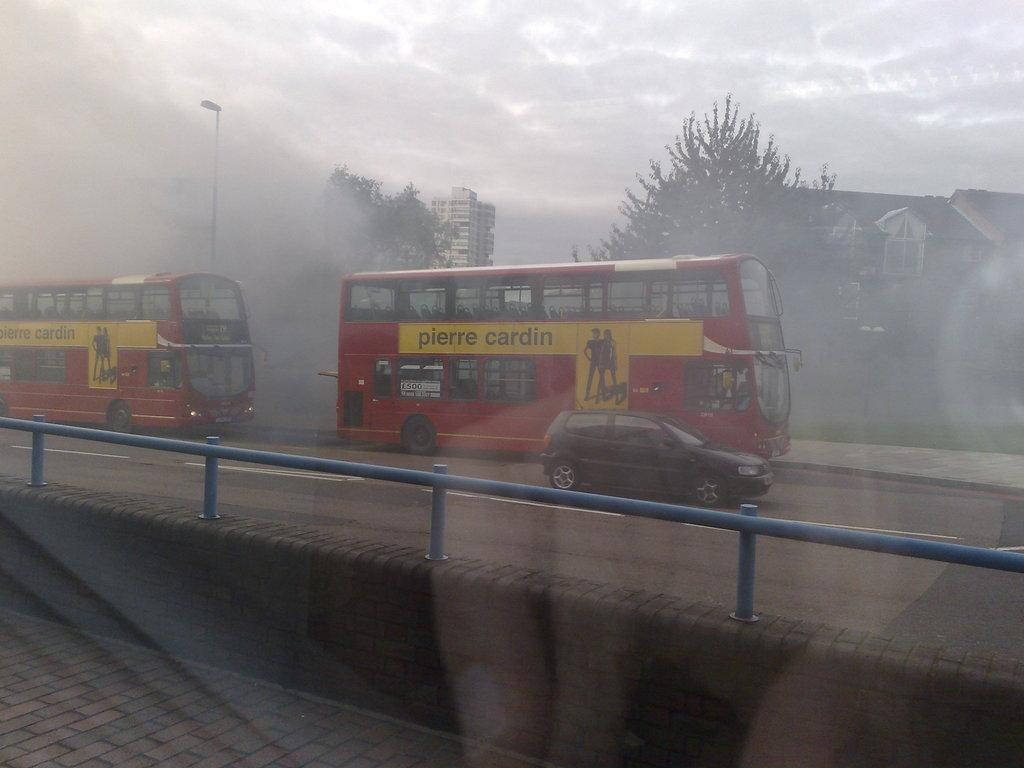Provide a one-sentence caption for the provided image. Double Decker bus with yellow stripe that reads pierre cardin driving in the rain. 